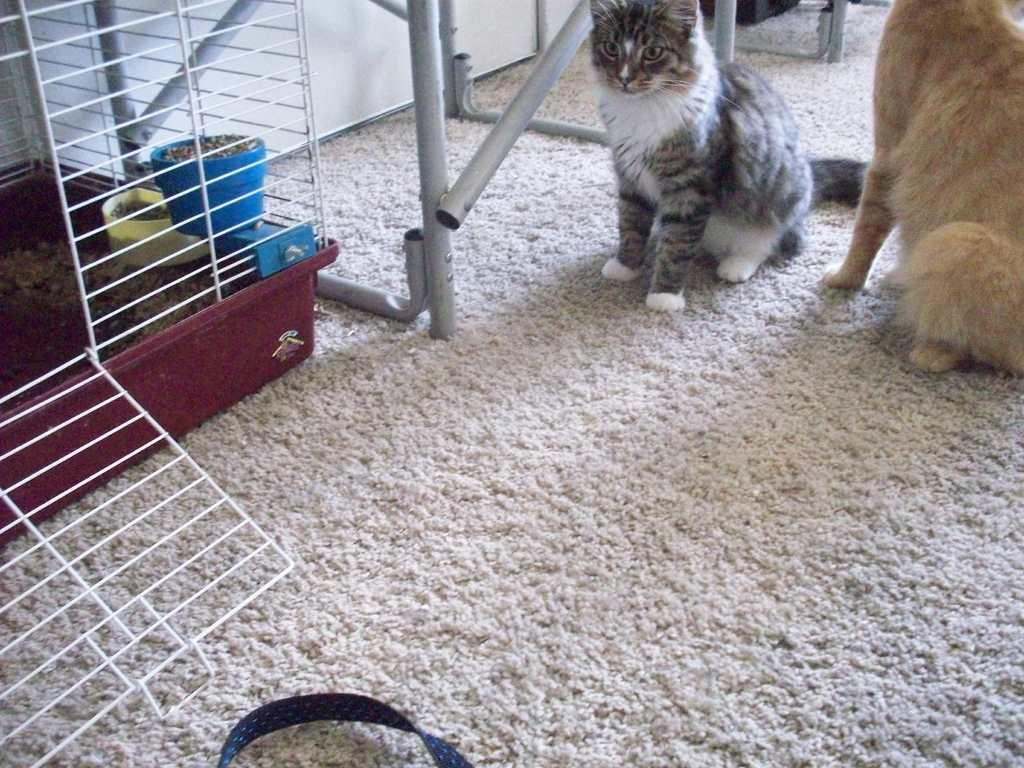What type of enclosure is present in the image? There is a cage in the image. What other objects can be seen in the image? There are boxes and metal rods visible in the image. What type of animal is present in the image? There is a cat in the image. What is the cat sitting on in the image? An animal, presumably the cat, is sitting on a floor mat in the image. Can you describe the setting where the image might have been taken? The image may have been taken in a hall. How many pipes are visible in the image? There are no pipes present in the image. What advice does the cat's uncle give in the image? There is no uncle present in the image, and therefore no advice can be given. 